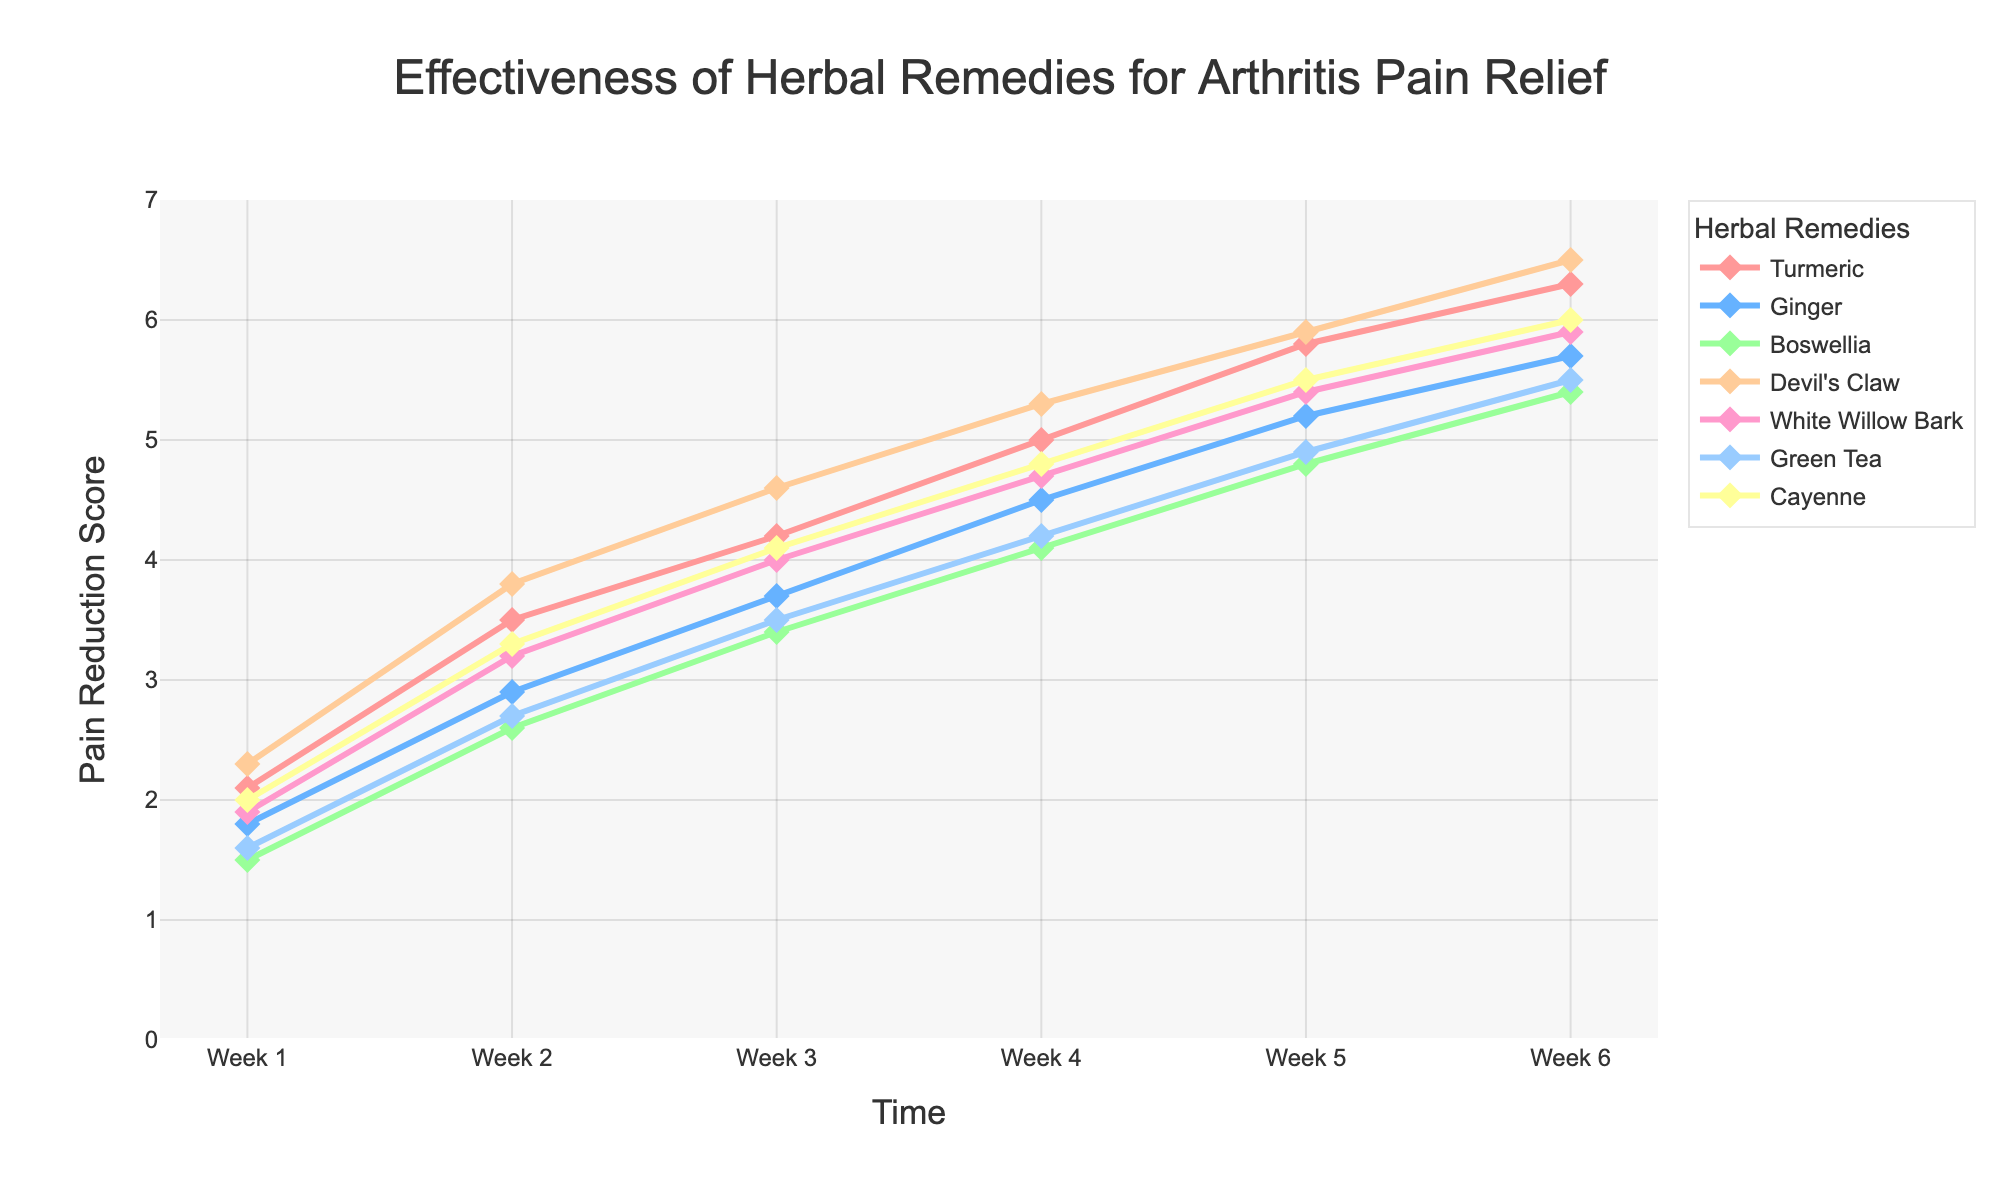Which herbal remedy had the highest pain reduction score at Week 6? By observing the y-values at Week 6 for each remedy, Devil's Claw has the highest score of 6.5.
Answer: Devil's Claw What is the difference in pain reduction score between Turmeric and Ginger at Week 4? The pain reduction score for Turmeric at Week 4 is 5.0 and for Ginger, it is 4.5. The difference is 5.0 - 4.5.
Answer: 0.5 Which two remedies had the closest pain reduction scores at Week 3? By examining the y-values for Week 3, Ginger (3.7) and Green Tea (3.5) have the closest pain reduction scores.
Answer: Ginger and Green Tea What is the average pain reduction score of Boswellia over the six weeks? Sum the scores for Boswellia (1.5 + 2.6 + 3.4 + 4.1 + 4.8 + 5.4) to get 21.8, then divide by 6 weeks.
Answer: 3.63 Which remedy showed the most consistent improvement in pain reduction scores over the six weeks? Boswellia shows an incrementally steady increase (from 1.5 to 5.4) over the weeks without drastic jumps or drops.
Answer: Boswellia What is the median pain reduction score of Devil's Claw at Week 6? Extract the scores at Week 6: [6.3, 5.7, 5.4, 6.5, 5.9, 5.5, 6.0], sort them: [5.4, 5.5, 5.7, 5.9, 6.0, 6.3, 6.5], and the median is the middle value.
Answer: 5.9 How many remedies exceeded a pain reduction score of 5.0 by Week 5? Count the number of entries that have a score greater than 5.0 at Week 5: Turmeric (5.8), Ginger (5.2), Devil's Claw (5.9), White Willow Bark (5.4), Cayenne (5.5).
Answer: 5 Which remedy had the steepest initial increase in pain reduction score from Week 1 to Week 2? Calculate the differences and identify the highest: Devil's Claw (2.3 to 3.8 = 1.5).
Answer: Devil's Claw What is the total pain reduction score of all remedies combined at Week 6? Sum the scores for all remedies at Week 6: 6.3 + 5.7 + 5.4 + 6.5 + 5.9 + 5.5 + 6.0.
Answer: 41.3 